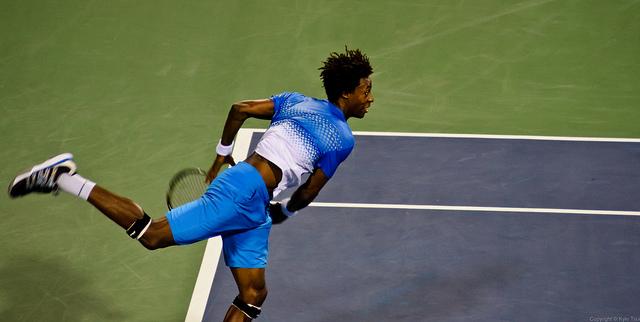Is this Gael Monfils?
Write a very short answer. Yes. What brand of sneakers is he wearing?
Be succinct. Adidas. What game is he playing?
Write a very short answer. Tennis. Is the man a tennis professional?
Answer briefly. Yes. 